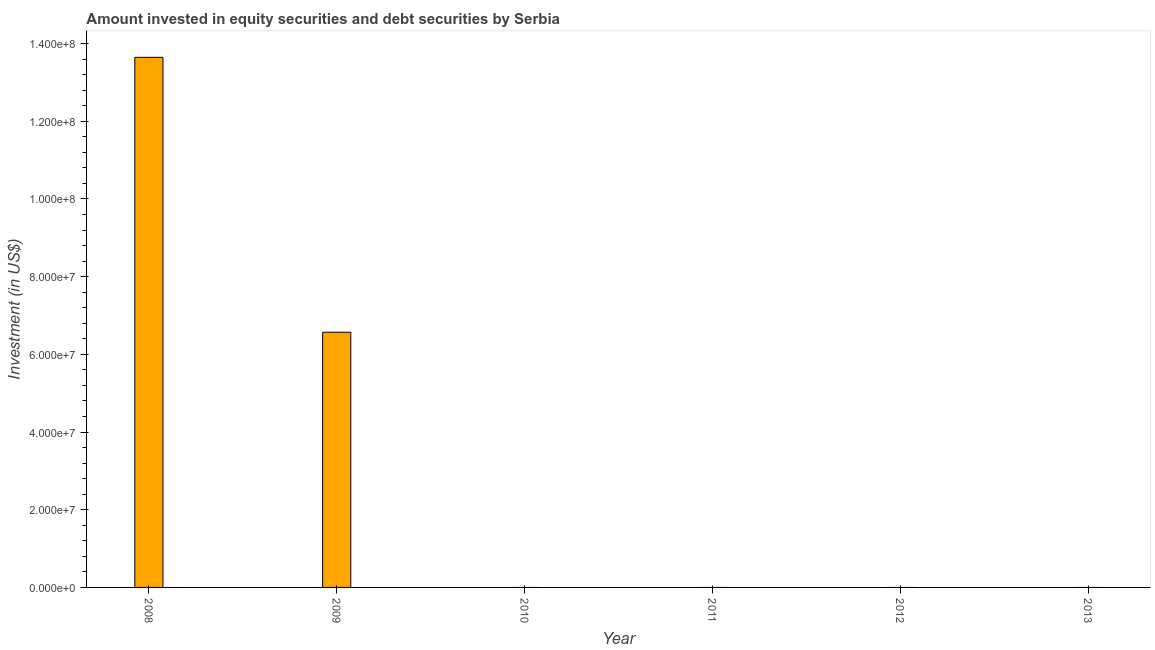Does the graph contain grids?
Keep it short and to the point. No. What is the title of the graph?
Provide a short and direct response. Amount invested in equity securities and debt securities by Serbia. What is the label or title of the Y-axis?
Provide a succinct answer. Investment (in US$). What is the portfolio investment in 2009?
Offer a very short reply. 6.57e+07. Across all years, what is the maximum portfolio investment?
Make the answer very short. 1.36e+08. What is the sum of the portfolio investment?
Keep it short and to the point. 2.02e+08. What is the average portfolio investment per year?
Offer a very short reply. 3.37e+07. In how many years, is the portfolio investment greater than 44000000 US$?
Offer a very short reply. 2. What is the difference between the highest and the lowest portfolio investment?
Your answer should be very brief. 1.36e+08. How many bars are there?
Provide a short and direct response. 2. Are all the bars in the graph horizontal?
Keep it short and to the point. No. How many years are there in the graph?
Your answer should be compact. 6. What is the difference between two consecutive major ticks on the Y-axis?
Your answer should be compact. 2.00e+07. What is the Investment (in US$) in 2008?
Keep it short and to the point. 1.36e+08. What is the Investment (in US$) of 2009?
Provide a short and direct response. 6.57e+07. What is the Investment (in US$) in 2010?
Ensure brevity in your answer.  0. What is the difference between the Investment (in US$) in 2008 and 2009?
Make the answer very short. 7.08e+07. What is the ratio of the Investment (in US$) in 2008 to that in 2009?
Provide a succinct answer. 2.08. 